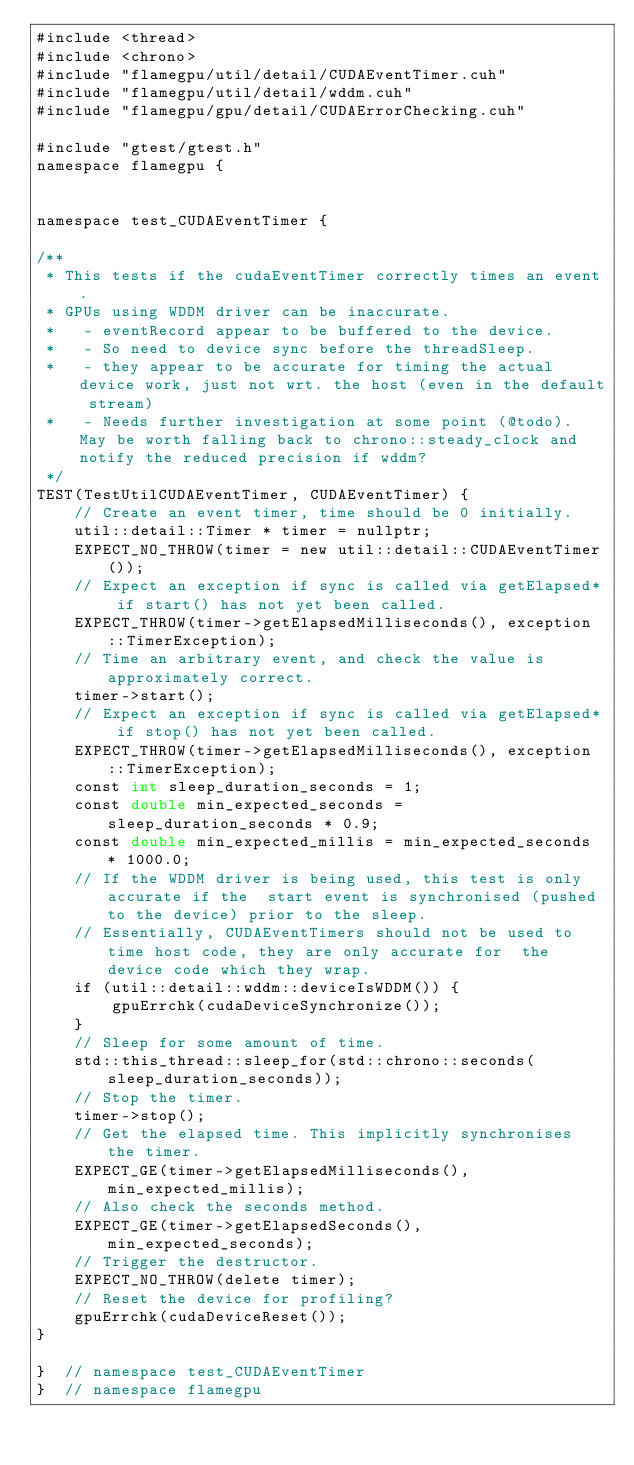<code> <loc_0><loc_0><loc_500><loc_500><_Cuda_>#include <thread>
#include <chrono>
#include "flamegpu/util/detail/CUDAEventTimer.cuh"
#include "flamegpu/util/detail/wddm.cuh"
#include "flamegpu/gpu/detail/CUDAErrorChecking.cuh"

#include "gtest/gtest.h"
namespace flamegpu {


namespace test_CUDAEventTimer {

/**
 * This tests if the cudaEventTimer correctly times an event. 
 * GPUs using WDDM driver can be inaccurate.
 *   - eventRecord appear to be buffered to the device. 
 *   - So need to device sync before the threadSleep.
 *   - they appear to be accurate for timing the actual device work, just not wrt. the host (even in the default stream)
 *   - Needs further investigation at some point (@todo). May be worth falling back to chrono::steady_clock and notify the reduced precision if wddm? 
 */
TEST(TestUtilCUDAEventTimer, CUDAEventTimer) {
    // Create an event timer, time should be 0 initially.
    util::detail::Timer * timer = nullptr;
    EXPECT_NO_THROW(timer = new util::detail::CUDAEventTimer());
    // Expect an exception if sync is called via getElapsed* if start() has not yet been called.
    EXPECT_THROW(timer->getElapsedMilliseconds(), exception::TimerException);
    // Time an arbitrary event, and check the value is approximately correct.
    timer->start();
    // Expect an exception if sync is called via getElapsed* if stop() has not yet been called.
    EXPECT_THROW(timer->getElapsedMilliseconds(), exception::TimerException);
    const int sleep_duration_seconds = 1;
    const double min_expected_seconds = sleep_duration_seconds * 0.9;
    const double min_expected_millis = min_expected_seconds * 1000.0;
    // If the WDDM driver is being used, this test is only accurate if the  start event is synchronised (pushed to the device) prior to the sleep.
    // Essentially, CUDAEventTimers should not be used to time host code, they are only accurate for  the device code which they wrap.
    if (util::detail::wddm::deviceIsWDDM()) {
        gpuErrchk(cudaDeviceSynchronize());
    }
    // Sleep for some amount of time.
    std::this_thread::sleep_for(std::chrono::seconds(sleep_duration_seconds));
    // Stop the timer.
    timer->stop();
    // Get the elapsed time. This implicitly synchronises the timer.
    EXPECT_GE(timer->getElapsedMilliseconds(), min_expected_millis);
    // Also check the seconds method.
    EXPECT_GE(timer->getElapsedSeconds(), min_expected_seconds);
    // Trigger the destructor.
    EXPECT_NO_THROW(delete timer);
    // Reset the device for profiling?
    gpuErrchk(cudaDeviceReset());
}

}  // namespace test_CUDAEventTimer
}  // namespace flamegpu
</code> 